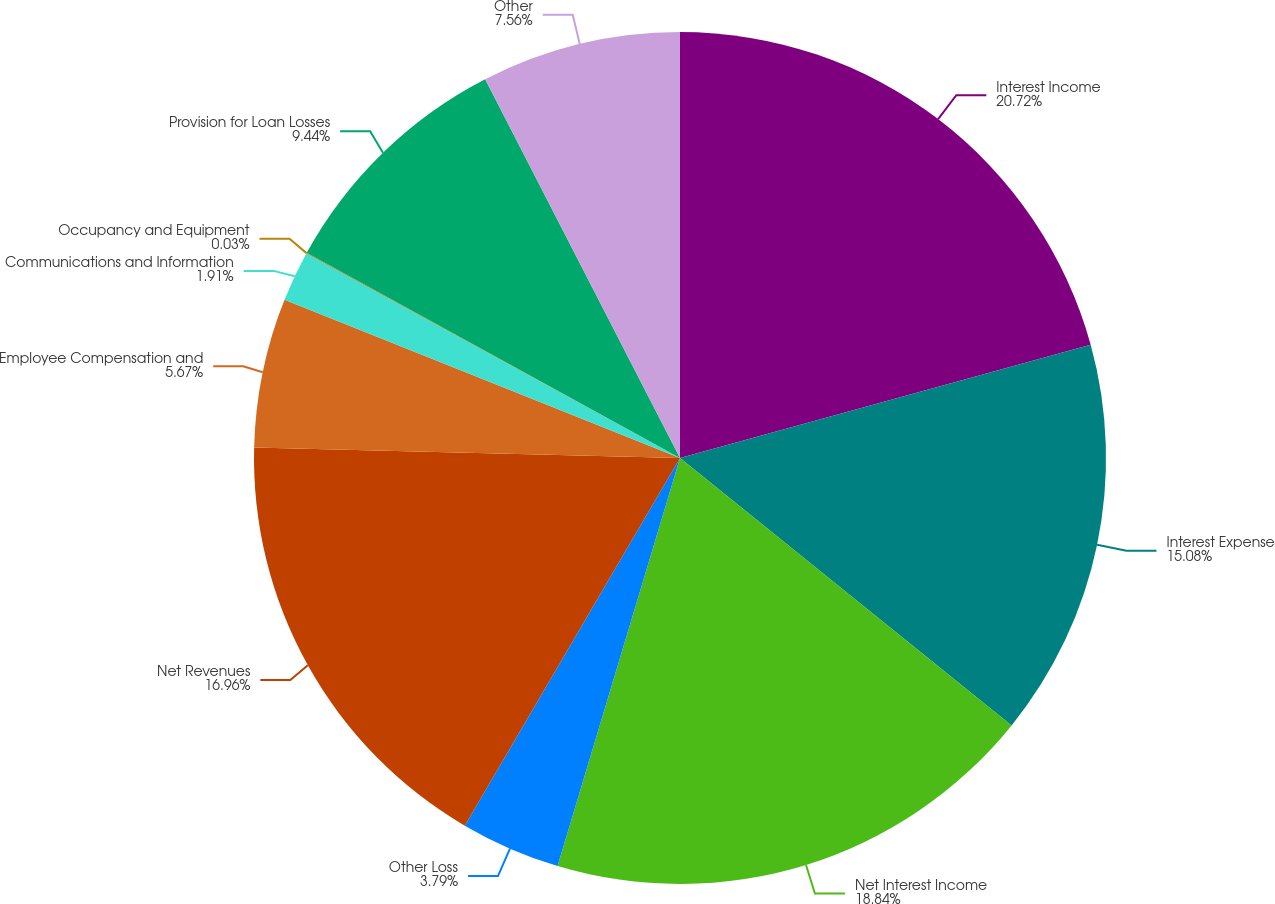Convert chart to OTSL. <chart><loc_0><loc_0><loc_500><loc_500><pie_chart><fcel>Interest Income<fcel>Interest Expense<fcel>Net Interest Income<fcel>Other Loss<fcel>Net Revenues<fcel>Employee Compensation and<fcel>Communications and Information<fcel>Occupancy and Equipment<fcel>Provision for Loan Losses<fcel>Other<nl><fcel>20.72%<fcel>15.08%<fcel>18.84%<fcel>3.79%<fcel>16.96%<fcel>5.67%<fcel>1.91%<fcel>0.03%<fcel>9.44%<fcel>7.56%<nl></chart> 